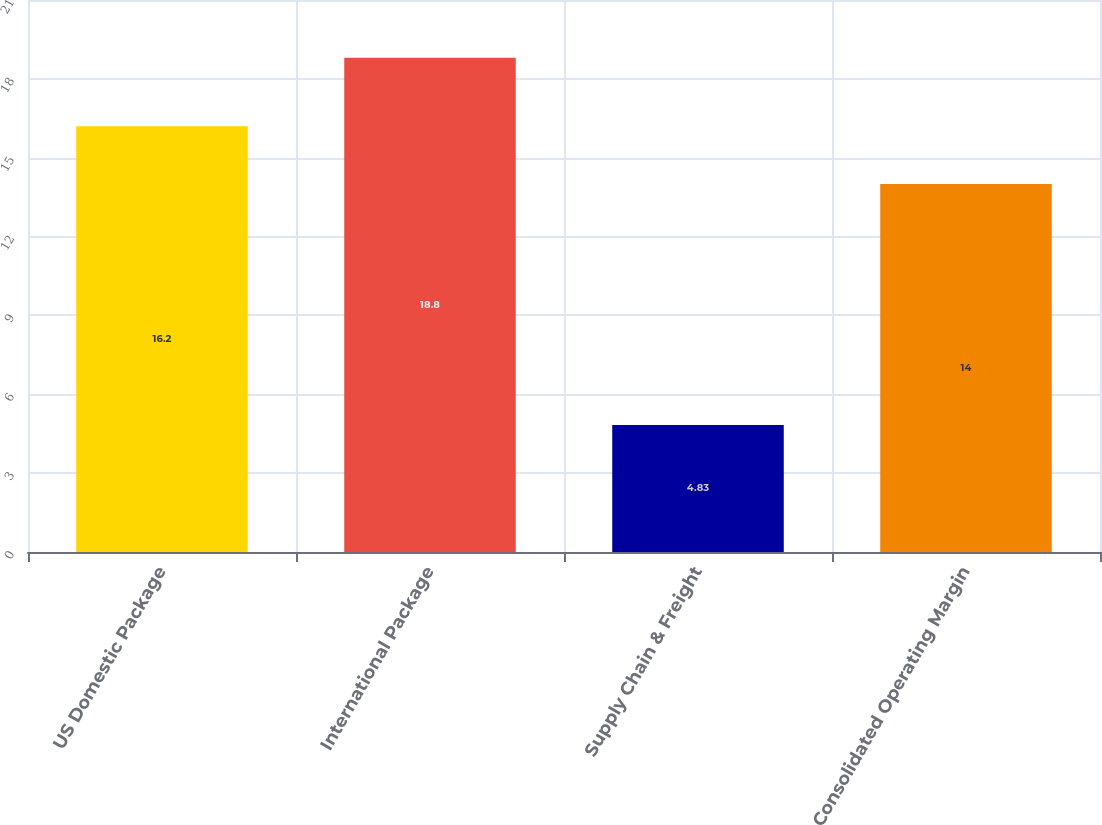<chart> <loc_0><loc_0><loc_500><loc_500><bar_chart><fcel>US Domestic Package<fcel>International Package<fcel>Supply Chain & Freight<fcel>Consolidated Operating Margin<nl><fcel>16.2<fcel>18.8<fcel>4.83<fcel>14<nl></chart> 